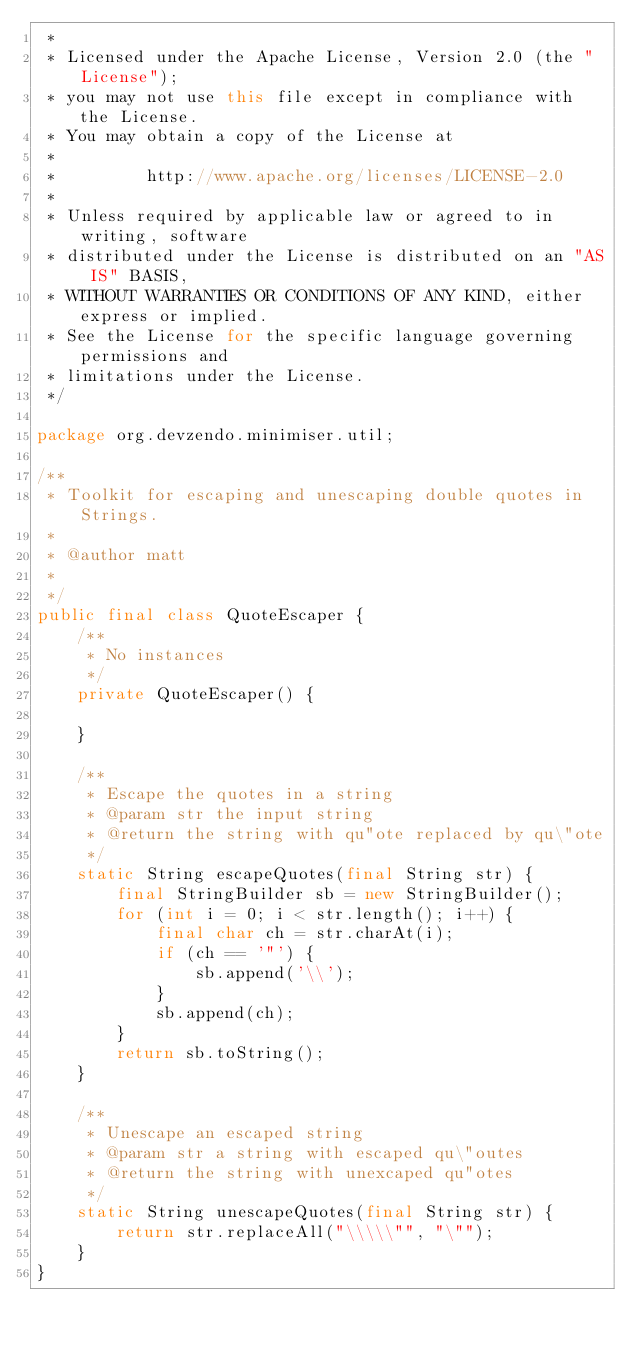Convert code to text. <code><loc_0><loc_0><loc_500><loc_500><_Java_> *
 * Licensed under the Apache License, Version 2.0 (the "License");
 * you may not use this file except in compliance with the License.
 * You may obtain a copy of the License at
 *
 *         http://www.apache.org/licenses/LICENSE-2.0
 *
 * Unless required by applicable law or agreed to in writing, software
 * distributed under the License is distributed on an "AS IS" BASIS,
 * WITHOUT WARRANTIES OR CONDITIONS OF ANY KIND, either express or implied.
 * See the License for the specific language governing permissions and
 * limitations under the License.
 */

package org.devzendo.minimiser.util;

/**
 * Toolkit for escaping and unescaping double quotes in Strings.
 * 
 * @author matt
 *
 */
public final class QuoteEscaper {
    /**
     * No instances
     */
    private QuoteEscaper() {
        
    }

    /**
     * Escape the quotes in a string
     * @param str the input string
     * @return the string with qu"ote replaced by qu\"ote
     */
    static String escapeQuotes(final String str) {
        final StringBuilder sb = new StringBuilder();
        for (int i = 0; i < str.length(); i++) {
            final char ch = str.charAt(i);
            if (ch == '"') {
                sb.append('\\');
            }
            sb.append(ch);
        }
        return sb.toString();
    }

    /**
     * Unescape an escaped string
     * @param str a string with escaped qu\"outes
     * @return the string with unexcaped qu"otes
     */
    static String unescapeQuotes(final String str) {
        return str.replaceAll("\\\\\"", "\"");
    }
}
</code> 